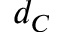<formula> <loc_0><loc_0><loc_500><loc_500>d _ { C }</formula> 